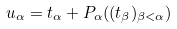Convert formula to latex. <formula><loc_0><loc_0><loc_500><loc_500>u _ { \alpha } = t _ { \alpha } + P _ { \alpha } ( ( t _ { \beta } ) _ { \beta < \alpha } )</formula> 